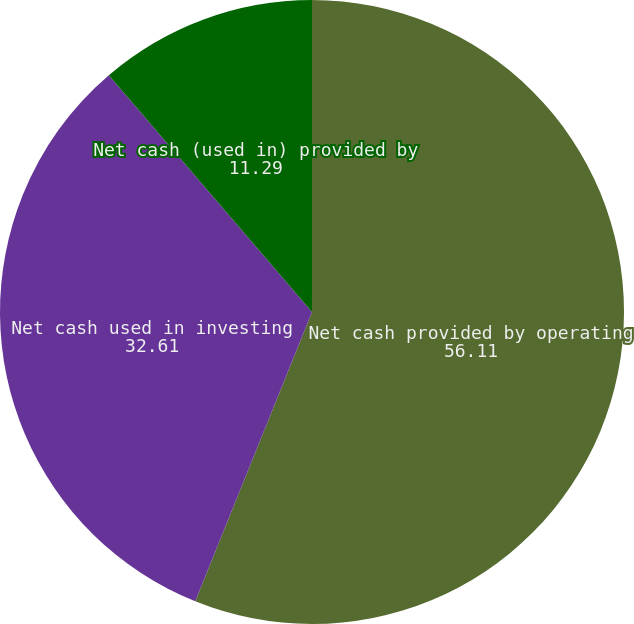Convert chart. <chart><loc_0><loc_0><loc_500><loc_500><pie_chart><fcel>Net cash provided by operating<fcel>Net cash used in investing<fcel>Net cash (used in) provided by<nl><fcel>56.11%<fcel>32.61%<fcel>11.29%<nl></chart> 